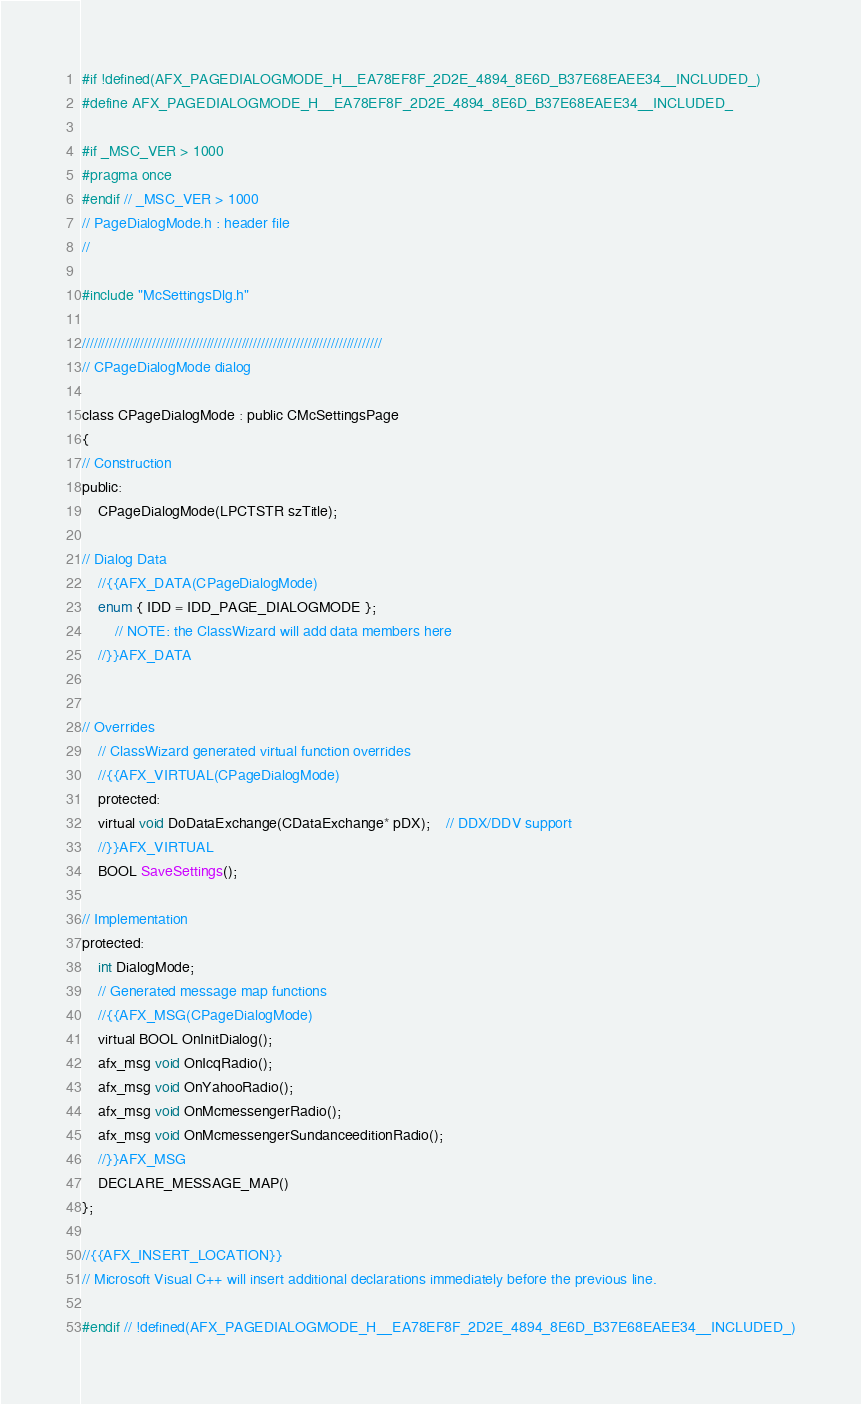<code> <loc_0><loc_0><loc_500><loc_500><_C_>#if !defined(AFX_PAGEDIALOGMODE_H__EA78EF8F_2D2E_4894_8E6D_B37E68EAEE34__INCLUDED_)
#define AFX_PAGEDIALOGMODE_H__EA78EF8F_2D2E_4894_8E6D_B37E68EAEE34__INCLUDED_

#if _MSC_VER > 1000
#pragma once
#endif // _MSC_VER > 1000
// PageDialogMode.h : header file
//

#include "McSettingsDlg.h"

/////////////////////////////////////////////////////////////////////////////
// CPageDialogMode dialog

class CPageDialogMode : public CMcSettingsPage
{
// Construction
public:
	CPageDialogMode(LPCTSTR szTitle);

// Dialog Data
	//{{AFX_DATA(CPageDialogMode)
	enum { IDD = IDD_PAGE_DIALOGMODE };
		// NOTE: the ClassWizard will add data members here
	//}}AFX_DATA


// Overrides
	// ClassWizard generated virtual function overrides
	//{{AFX_VIRTUAL(CPageDialogMode)
	protected:
	virtual void DoDataExchange(CDataExchange* pDX);    // DDX/DDV support
	//}}AFX_VIRTUAL
	BOOL SaveSettings();

// Implementation
protected:
	int DialogMode;
	// Generated message map functions
	//{{AFX_MSG(CPageDialogMode)
	virtual BOOL OnInitDialog();
	afx_msg void OnIcqRadio();
	afx_msg void OnYahooRadio();
	afx_msg void OnMcmessengerRadio();
	afx_msg void OnMcmessengerSundanceeditionRadio();
	//}}AFX_MSG
	DECLARE_MESSAGE_MAP()
};

//{{AFX_INSERT_LOCATION}}
// Microsoft Visual C++ will insert additional declarations immediately before the previous line.

#endif // !defined(AFX_PAGEDIALOGMODE_H__EA78EF8F_2D2E_4894_8E6D_B37E68EAEE34__INCLUDED_)
</code> 